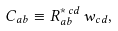<formula> <loc_0><loc_0><loc_500><loc_500>C _ { a b } \equiv R _ { a b } ^ { * \, c d } \, w _ { c d } ,</formula> 